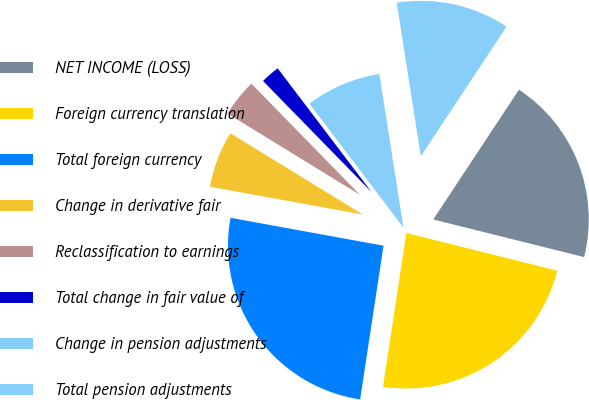Convert chart. <chart><loc_0><loc_0><loc_500><loc_500><pie_chart><fcel>NET INCOME (LOSS)<fcel>Foreign currency translation<fcel>Total foreign currency<fcel>Change in derivative fair<fcel>Reclassification to earnings<fcel>Total change in fair value of<fcel>Change in pension adjustments<fcel>Total pension adjustments<nl><fcel>19.6%<fcel>23.51%<fcel>25.47%<fcel>5.89%<fcel>3.93%<fcel>1.98%<fcel>7.85%<fcel>11.77%<nl></chart> 